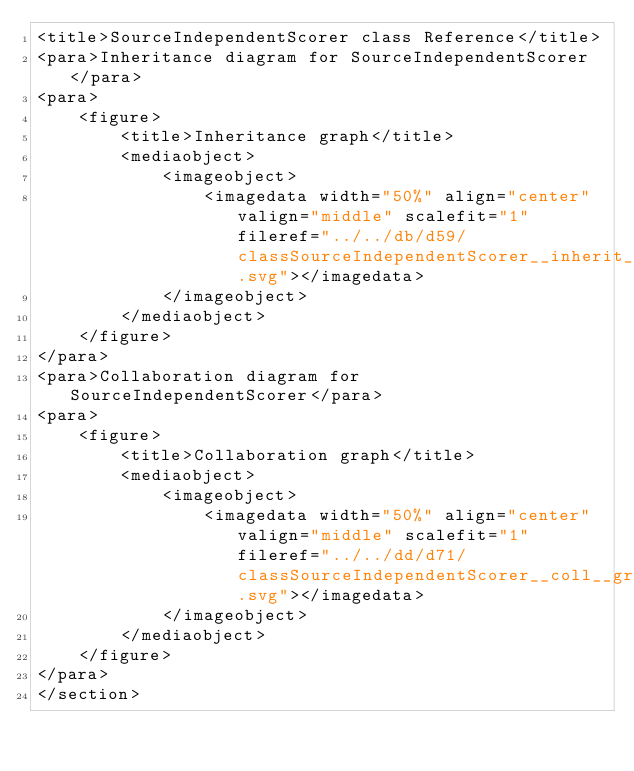Convert code to text. <code><loc_0><loc_0><loc_500><loc_500><_XML_><title>SourceIndependentScorer class Reference</title>
<para>Inheritance diagram for SourceIndependentScorer</para>
<para>
    <figure>
        <title>Inheritance graph</title>
        <mediaobject>
            <imageobject>
                <imagedata width="50%" align="center" valign="middle" scalefit="1" fileref="../../db/d59/classSourceIndependentScorer__inherit__graph.svg"></imagedata>
            </imageobject>
        </mediaobject>
    </figure>
</para>
<para>Collaboration diagram for SourceIndependentScorer</para>
<para>
    <figure>
        <title>Collaboration graph</title>
        <mediaobject>
            <imageobject>
                <imagedata width="50%" align="center" valign="middle" scalefit="1" fileref="../../dd/d71/classSourceIndependentScorer__coll__graph.svg"></imagedata>
            </imageobject>
        </mediaobject>
    </figure>
</para>
</section>
</code> 